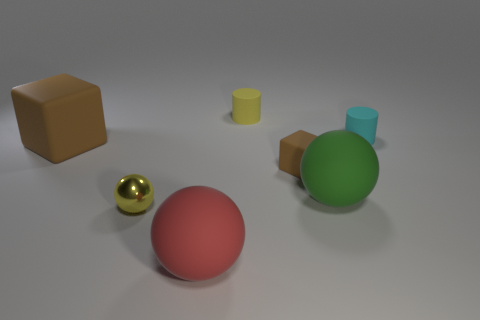Add 2 matte spheres. How many objects exist? 9 Subtract all cylinders. How many objects are left? 5 Subtract all tiny yellow balls. Subtract all big objects. How many objects are left? 3 Add 4 brown matte cubes. How many brown matte cubes are left? 6 Add 2 big red spheres. How many big red spheres exist? 3 Subtract 0 gray spheres. How many objects are left? 7 